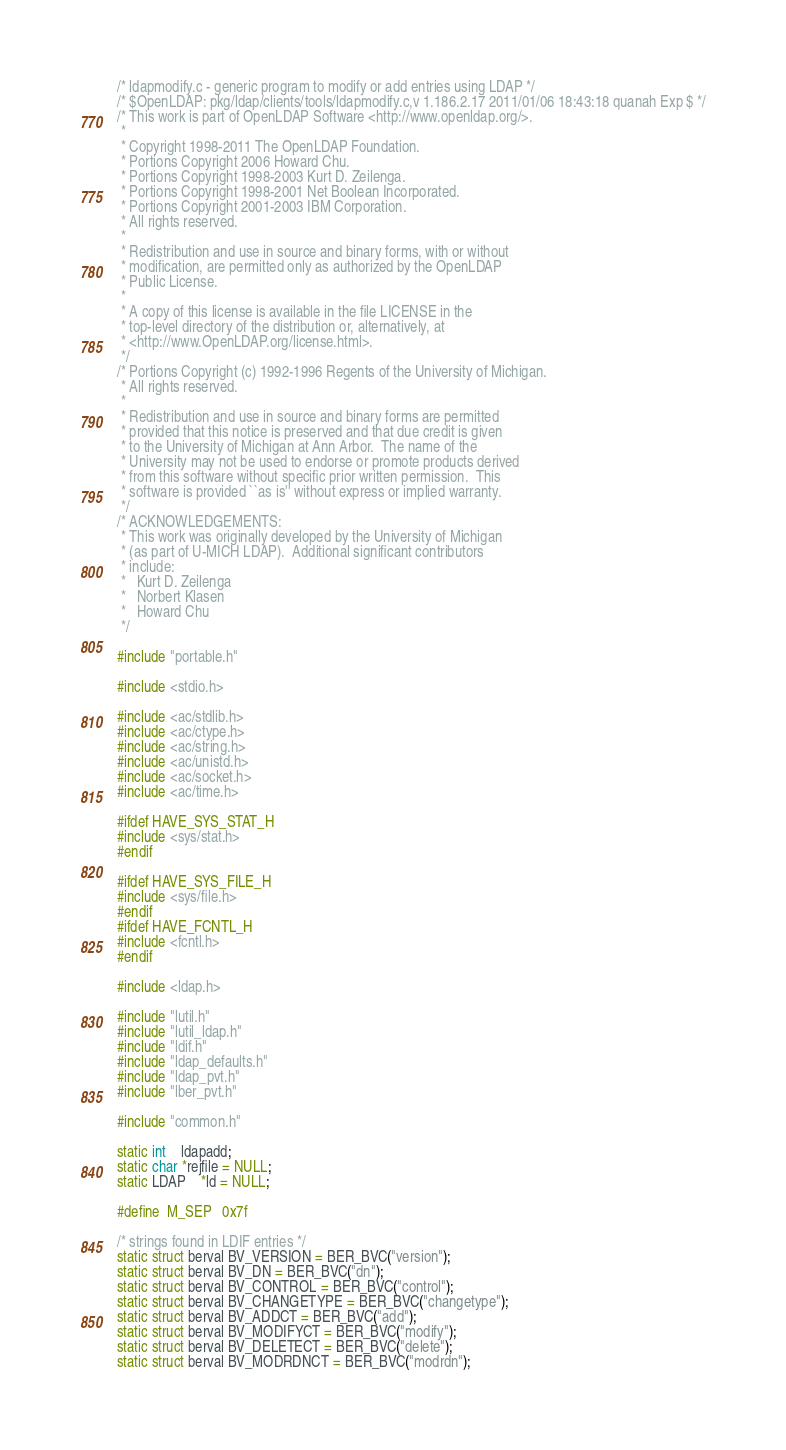<code> <loc_0><loc_0><loc_500><loc_500><_C_>/* ldapmodify.c - generic program to modify or add entries using LDAP */
/* $OpenLDAP: pkg/ldap/clients/tools/ldapmodify.c,v 1.186.2.17 2011/01/06 18:43:18 quanah Exp $ */
/* This work is part of OpenLDAP Software <http://www.openldap.org/>.
 *
 * Copyright 1998-2011 The OpenLDAP Foundation.
 * Portions Copyright 2006 Howard Chu.
 * Portions Copyright 1998-2003 Kurt D. Zeilenga.
 * Portions Copyright 1998-2001 Net Boolean Incorporated.
 * Portions Copyright 2001-2003 IBM Corporation.
 * All rights reserved.
 *
 * Redistribution and use in source and binary forms, with or without
 * modification, are permitted only as authorized by the OpenLDAP
 * Public License.
 *
 * A copy of this license is available in the file LICENSE in the
 * top-level directory of the distribution or, alternatively, at
 * <http://www.OpenLDAP.org/license.html>.
 */
/* Portions Copyright (c) 1992-1996 Regents of the University of Michigan.
 * All rights reserved.
 *
 * Redistribution and use in source and binary forms are permitted
 * provided that this notice is preserved and that due credit is given
 * to the University of Michigan at Ann Arbor.  The name of the
 * University may not be used to endorse or promote products derived
 * from this software without specific prior written permission.  This
 * software is provided ``as is'' without express or implied warranty.
 */
/* ACKNOWLEDGEMENTS:
 * This work was originally developed by the University of Michigan
 * (as part of U-MICH LDAP).  Additional significant contributors
 * include:
 *   Kurt D. Zeilenga
 *   Norbert Klasen
 *   Howard Chu
 */

#include "portable.h"

#include <stdio.h>

#include <ac/stdlib.h>
#include <ac/ctype.h>
#include <ac/string.h>
#include <ac/unistd.h>
#include <ac/socket.h>
#include <ac/time.h>

#ifdef HAVE_SYS_STAT_H
#include <sys/stat.h>
#endif

#ifdef HAVE_SYS_FILE_H
#include <sys/file.h>
#endif
#ifdef HAVE_FCNTL_H
#include <fcntl.h>
#endif

#include <ldap.h>

#include "lutil.h"
#include "lutil_ldap.h"
#include "ldif.h"
#include "ldap_defaults.h"
#include "ldap_pvt.h"
#include "lber_pvt.h"

#include "common.h"

static int	ldapadd;
static char *rejfile = NULL;
static LDAP	*ld = NULL;

#define	M_SEP	0x7f

/* strings found in LDIF entries */
static struct berval BV_VERSION = BER_BVC("version");
static struct berval BV_DN = BER_BVC("dn");
static struct berval BV_CONTROL = BER_BVC("control");
static struct berval BV_CHANGETYPE = BER_BVC("changetype");
static struct berval BV_ADDCT = BER_BVC("add");
static struct berval BV_MODIFYCT = BER_BVC("modify");
static struct berval BV_DELETECT = BER_BVC("delete");
static struct berval BV_MODRDNCT = BER_BVC("modrdn");</code> 